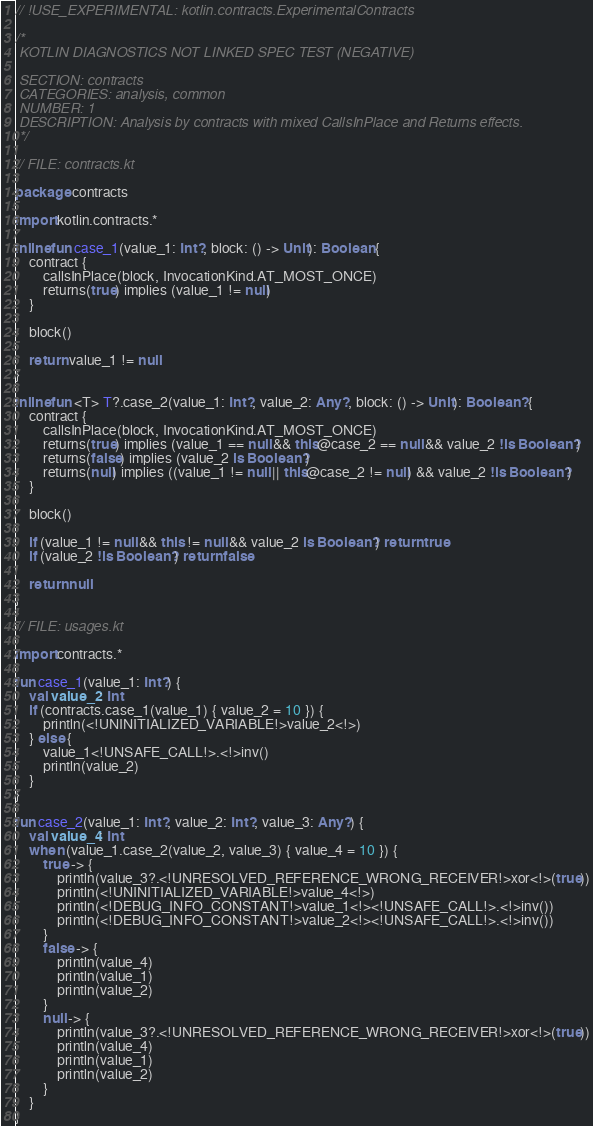Convert code to text. <code><loc_0><loc_0><loc_500><loc_500><_Kotlin_>// !USE_EXPERIMENTAL: kotlin.contracts.ExperimentalContracts

/*
 KOTLIN DIAGNOSTICS NOT LINKED SPEC TEST (NEGATIVE)

 SECTION: contracts
 CATEGORIES: analysis, common
 NUMBER: 1
 DESCRIPTION: Analysis by contracts with mixed CallsInPlace and Returns effects.
 */

// FILE: contracts.kt

package contracts

import kotlin.contracts.*

inline fun case_1(value_1: Int?, block: () -> Unit): Boolean {
    contract {
        callsInPlace(block, InvocationKind.AT_MOST_ONCE)
        returns(true) implies (value_1 != null)
    }

    block()

    return value_1 != null
}

inline fun <T> T?.case_2(value_1: Int?, value_2: Any?, block: () -> Unit): Boolean? {
    contract {
        callsInPlace(block, InvocationKind.AT_MOST_ONCE)
        returns(true) implies (value_1 == null && this@case_2 == null && value_2 !is Boolean?)
        returns(false) implies (value_2 is Boolean?)
        returns(null) implies ((value_1 != null || this@case_2 != null) && value_2 !is Boolean?)
    }

    block()

    if (value_1 != null && this != null && value_2 is Boolean?) return true
    if (value_2 !is Boolean?) return false

    return null
}

// FILE: usages.kt

import contracts.*

fun case_1(value_1: Int?) {
    val value_2: Int
    if (contracts.case_1(value_1) { value_2 = 10 }) {
        println(<!UNINITIALIZED_VARIABLE!>value_2<!>)
    } else {
        value_1<!UNSAFE_CALL!>.<!>inv()
        println(value_2)
    }
}

fun case_2(value_1: Int?, value_2: Int?, value_3: Any?) {
    val value_4: Int
    when (value_1.case_2(value_2, value_3) { value_4 = 10 }) {
        true -> {
            println(value_3?.<!UNRESOLVED_REFERENCE_WRONG_RECEIVER!>xor<!>(true))
            println(<!UNINITIALIZED_VARIABLE!>value_4<!>)
            println(<!DEBUG_INFO_CONSTANT!>value_1<!><!UNSAFE_CALL!>.<!>inv())
            println(<!DEBUG_INFO_CONSTANT!>value_2<!><!UNSAFE_CALL!>.<!>inv())
        }
        false -> {
            println(value_4)
            println(value_1)
            println(value_2)
        }
        null -> {
            println(value_3?.<!UNRESOLVED_REFERENCE_WRONG_RECEIVER!>xor<!>(true))
            println(value_4)
            println(value_1)
            println(value_2)
        }
    }
}
</code> 